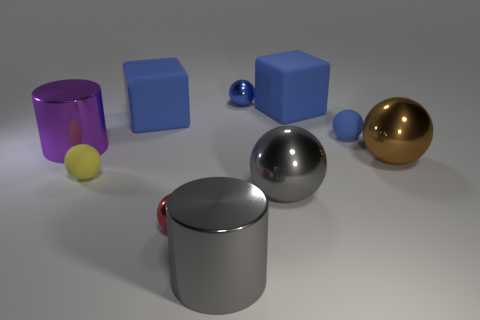What could be the purpose of arranging these objects together? The arrangement of these objects might serve educational purposes, such as demonstrating concepts of geometry, material, and light in a three-dimensional space or simply for aesthetic visualization. 